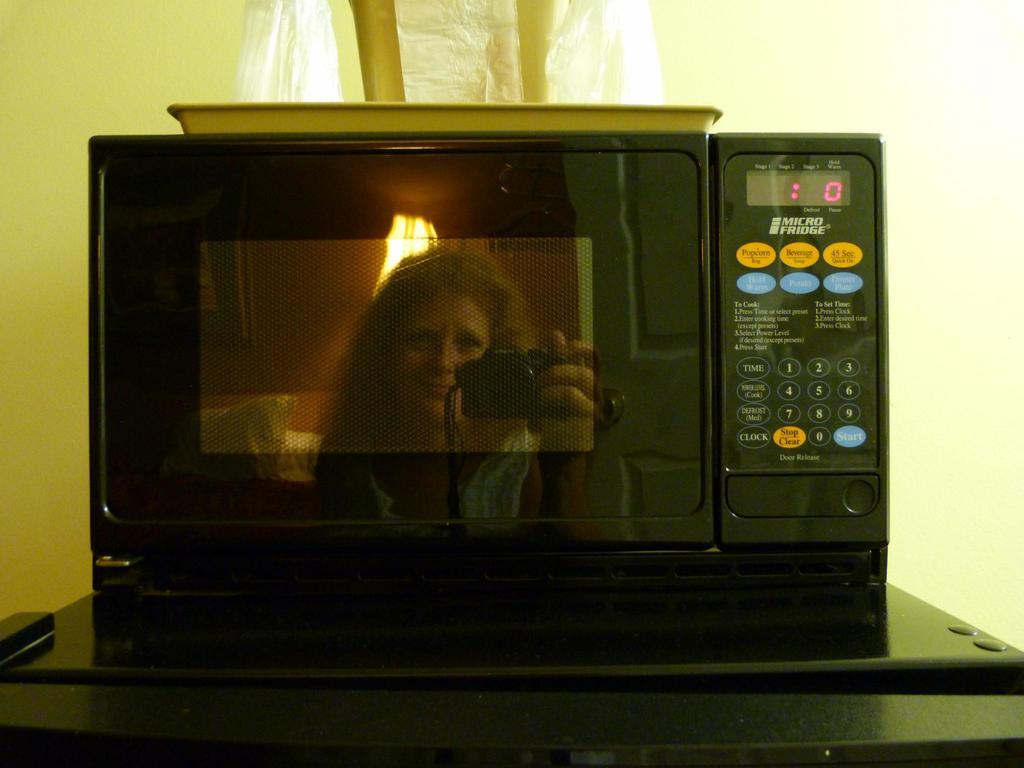<image>
Describe the image concisely. a woman in a reflection of a Micro fridge microwave with buttons for Popcorn 